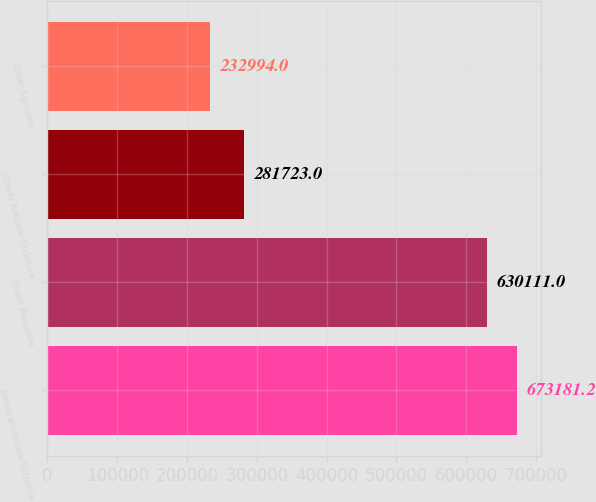Convert chart. <chart><loc_0><loc_0><loc_500><loc_500><bar_chart><fcel>American Income Exclusive<fcel>Direct Response<fcel>Liberty National Exclusive<fcel>Other Agencies<nl><fcel>673181<fcel>630111<fcel>281723<fcel>232994<nl></chart> 